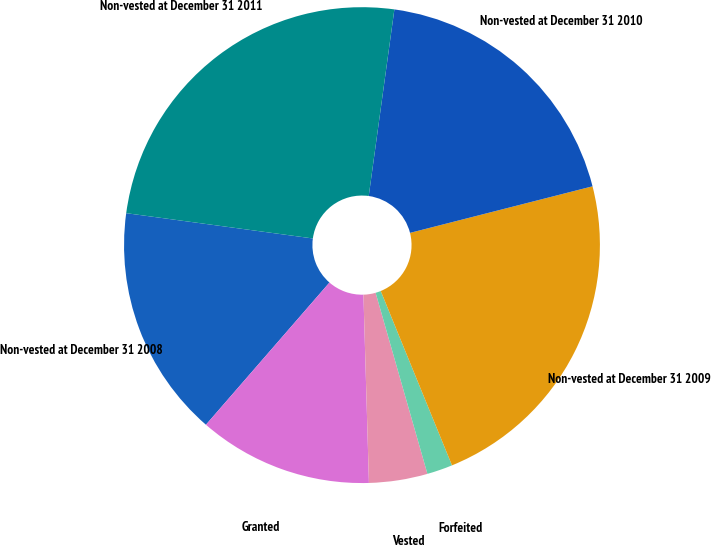<chart> <loc_0><loc_0><loc_500><loc_500><pie_chart><fcel>Non-vested at December 31 2008<fcel>Granted<fcel>Vested<fcel>Forfeited<fcel>Non-vested at December 31 2009<fcel>Non-vested at December 31 2010<fcel>Non-vested at December 31 2011<nl><fcel>15.76%<fcel>11.85%<fcel>3.97%<fcel>1.74%<fcel>22.8%<fcel>18.85%<fcel>25.03%<nl></chart> 